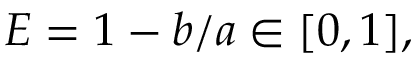<formula> <loc_0><loc_0><loc_500><loc_500>E = 1 - b / a \in [ 0 , 1 ] ,</formula> 